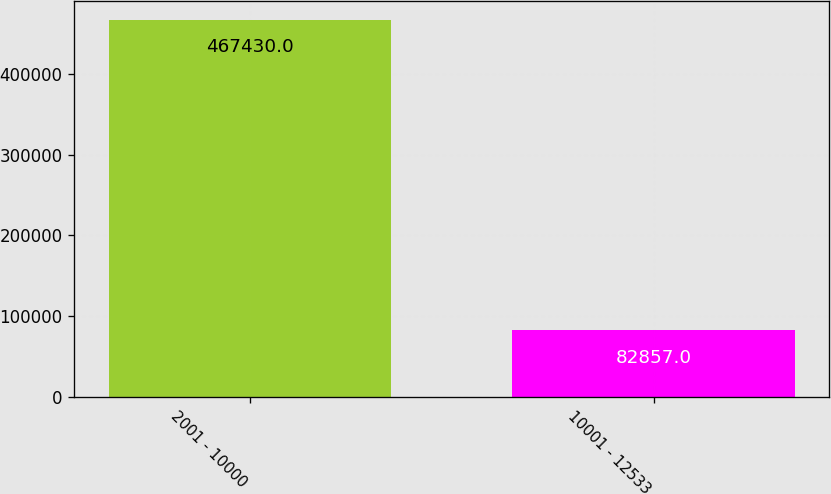Convert chart. <chart><loc_0><loc_0><loc_500><loc_500><bar_chart><fcel>2001 - 10000<fcel>10001 - 12533<nl><fcel>467430<fcel>82857<nl></chart> 